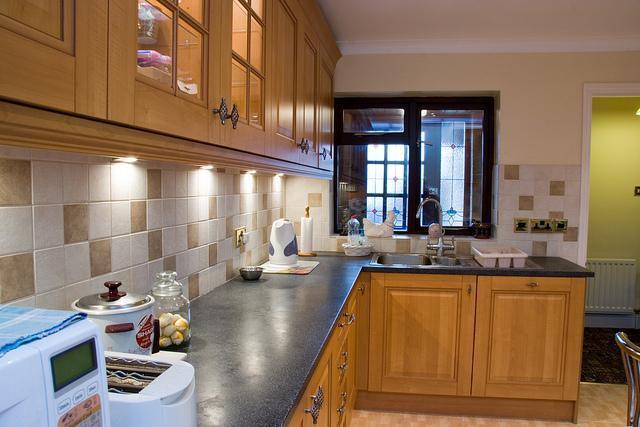How many books are pictured?
Give a very brief answer. 0. 